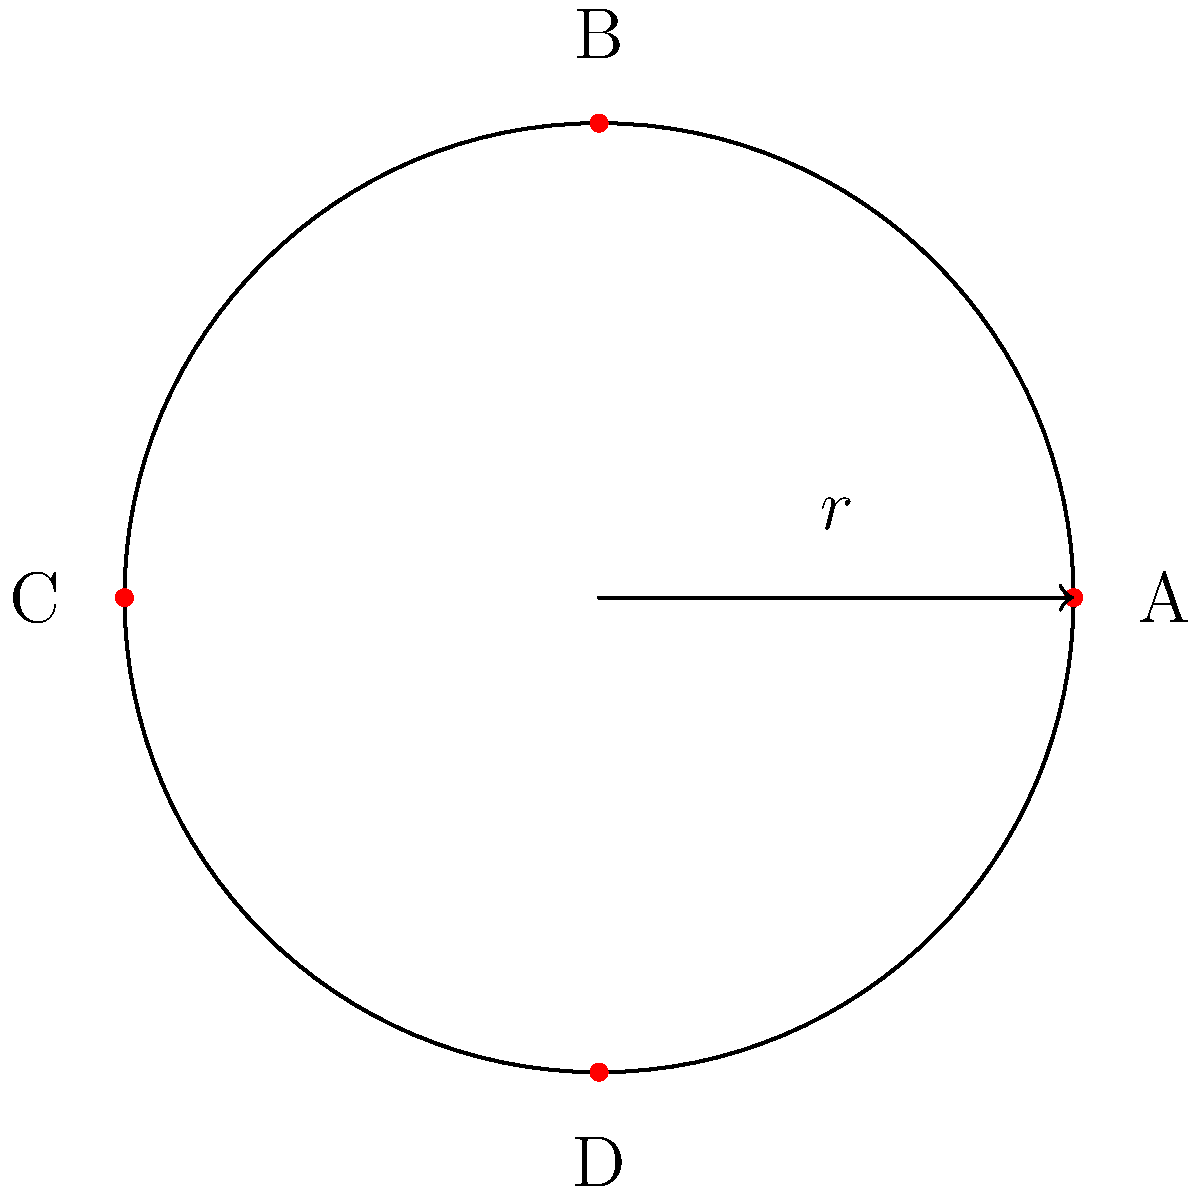Consider the stage layout for a rock concert shown above, where A, B, C, and D represent possible positions for band members. The stage has rotational symmetry of order 4 and reflection symmetry across 4 axes. Which element of the dihedral group $D_4$ corresponds to rotating the stage layout 90° clockwise? To solve this problem, let's break it down step-by-step:

1) The dihedral group $D_4$ represents the symmetries of a square or, in this case, our circular stage with 4 equally spaced positions.

2) $D_4$ has 8 elements in total:
   - The identity element (e)
   - Three rotations (90°, 180°, 270° clockwise)
   - Four reflections (across the two diagonals and two perpendicular bisectors)

3) We're asked about a 90° clockwise rotation. In group theory notation, this is often represented as $r$ (for rotation).

4) To visualize this rotation:
   - A would move to D
   - D would move to C
   - C would move to B
   - B would move to A

5) In cycle notation, this would be written as (ADCB).

6) In $D_4$, the elements are often labeled as:
   - $e$ (identity)
   - $r$ (90° clockwise rotation)
   - $r^2$ (180° rotation)
   - $r^3$ (270° clockwise rotation, or 90° counterclockwise)
   - $s, sr, sr^2, sr^3$ (the four reflections)

7) Therefore, the 90° clockwise rotation corresponds to the element $r$ in $D_4$.
Answer: $r$ 